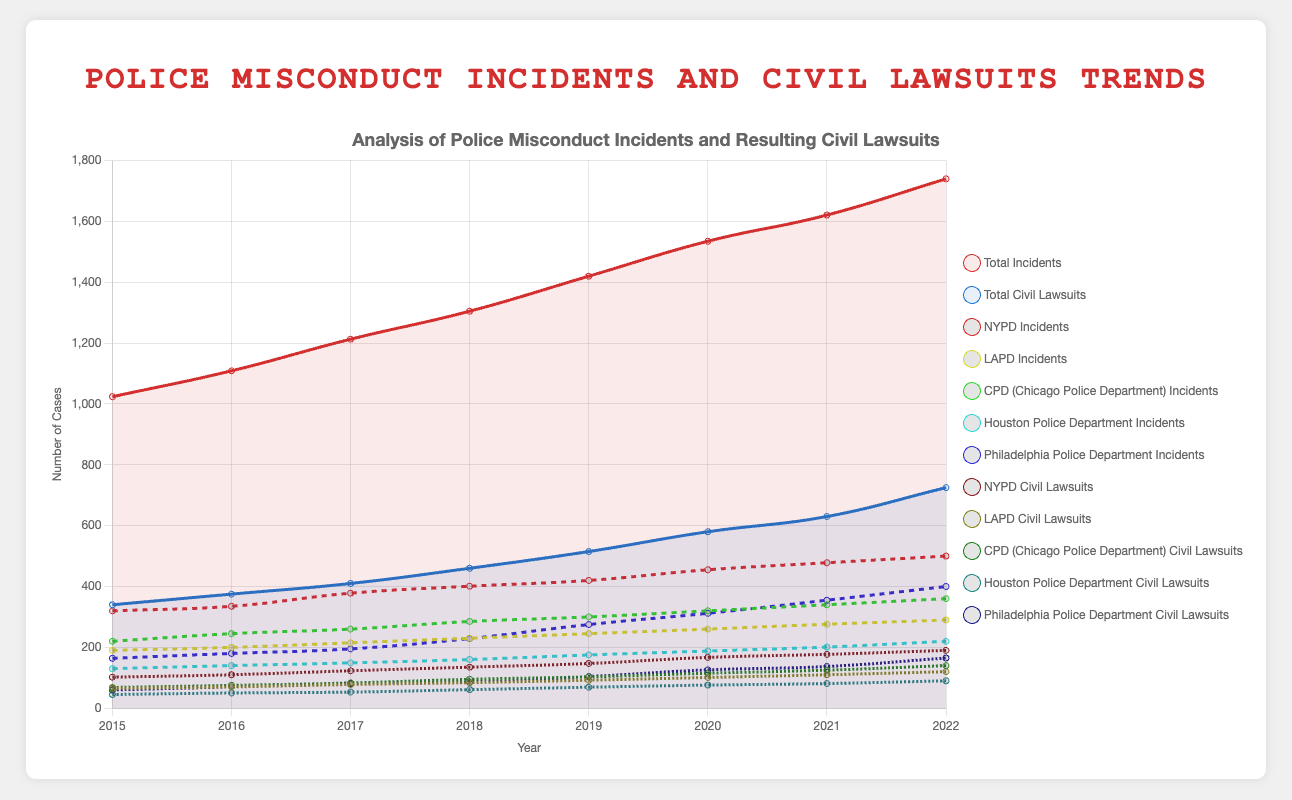Which years had the highest number of civil lawsuits filed? The figure shows a line representing the total number of civil lawsuits over the years. The year 2022 has the highest point on this line, followed by 2021 and 2020.
Answer: 2022 What is the overall trend of police misconduct incidents from 2015 to 2022? By observing the line representing total incidents, it is clear that the number of incidents has consistently increased each year from 2015 to 2022.
Answer: Increasing How do the number of incidents in the NYPD in 2022 compare to 2018? The line representing NYPD incidents shows that the number of incidents in 2018 is around 401, and in 2022, it is around 500, indicating an increase.
Answer: Increased Which department saw the highest rise in civil lawsuits between 2015 and 2022? By comparing the end points of each department's civil lawsuit trend line, the Philadelphia Police Department shows the largest increase from around 60 in 2015 to approximately 165 in 2022.
Answer: Philadelphia Police Department What is the difference between the total incidents and total civil lawsuits in 2020? The figure shows that the number of incidents in 2020 is around 1535, and the number of civil lawsuits is around 580. The difference is 1535 - 580 = 955.
Answer: 955 For which year does the difference between NYPD incidents and LAPD incidents appear the greatest? Comparing the two lines, the greatest gap appears in 2022, where NYPD incidents are around 500 and LAPD incidents are around 290.
Answer: 2022 How did the number of civil lawsuits filed against the LAPD change between 2015 and 2022? The trend line for LAPD civil lawsuits shows an increase from around 65 in 2015 to approximately 120 in 2022.
Answer: Increased On average, how many incidents occurred per year for the CPD between 2015 and 2022? Sum the incidents for CPD (220 + 245 + 260 + 285 + 300 + 320 + 340 + 360 = 2330) and divide by the number of years (8). 2330 / 8 = 291.25.
Answer: 291.25 Which department had the least number of civil lawsuits in 2022? By looking at the endpoints of the civil lawsuit lines, the Houston Police Department had the least number, with approximately 90 lawsuits in 2022.
Answer: Houston Police Department 